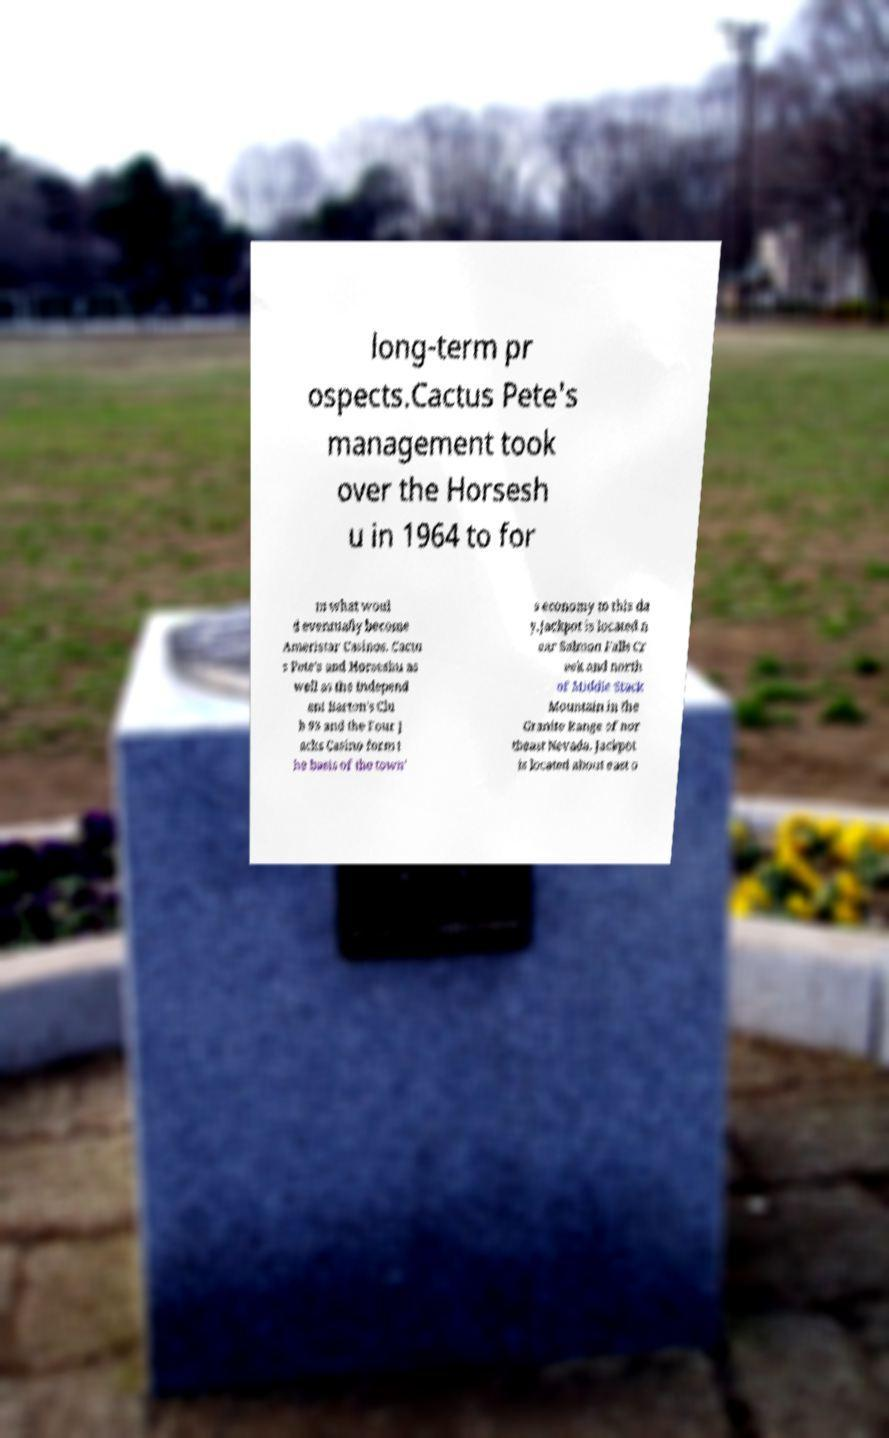What messages or text are displayed in this image? I need them in a readable, typed format. long-term pr ospects.Cactus Pete's management took over the Horsesh u in 1964 to for m what woul d eventually become Ameristar Casinos. Cactu s Pete's and Horseshu as well as the independ ent Barton's Clu b 93 and the Four J acks Casino form t he basis of the town' s economy to this da y.Jackpot is located n ear Salmon Falls Cr eek and north of Middle Stack Mountain in the Granite Range of nor theast Nevada. Jackpot is located about east o 